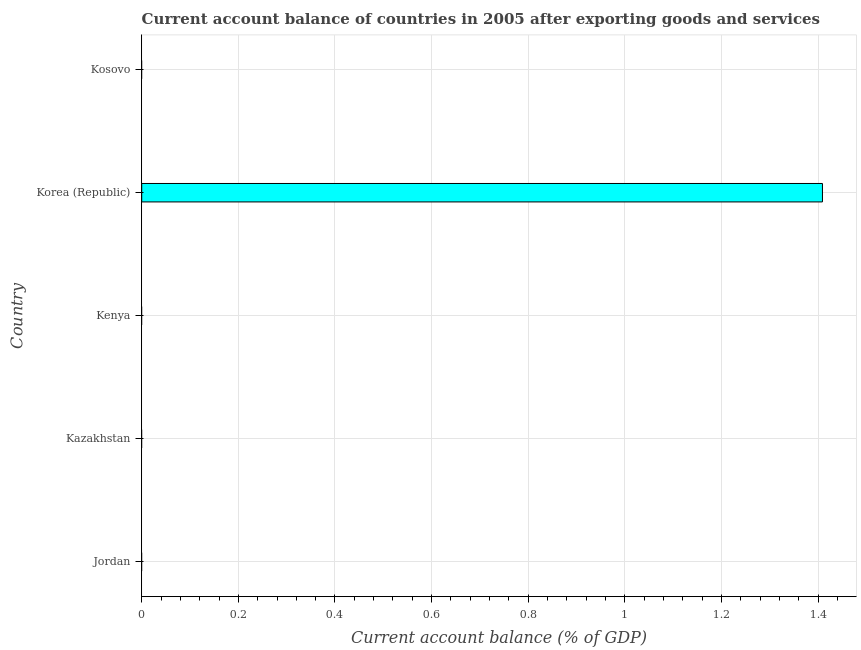Does the graph contain any zero values?
Make the answer very short. Yes. What is the title of the graph?
Provide a succinct answer. Current account balance of countries in 2005 after exporting goods and services. What is the label or title of the X-axis?
Provide a short and direct response. Current account balance (% of GDP). What is the current account balance in Kosovo?
Your answer should be very brief. 0. Across all countries, what is the maximum current account balance?
Offer a terse response. 1.41. In which country was the current account balance maximum?
Offer a terse response. Korea (Republic). What is the sum of the current account balance?
Provide a short and direct response. 1.41. What is the average current account balance per country?
Make the answer very short. 0.28. What is the median current account balance?
Offer a terse response. 0. In how many countries, is the current account balance greater than 0.56 %?
Offer a terse response. 1. What is the difference between the highest and the lowest current account balance?
Ensure brevity in your answer.  1.41. In how many countries, is the current account balance greater than the average current account balance taken over all countries?
Offer a terse response. 1. Are all the bars in the graph horizontal?
Your answer should be very brief. Yes. How many countries are there in the graph?
Give a very brief answer. 5. Are the values on the major ticks of X-axis written in scientific E-notation?
Make the answer very short. No. What is the Current account balance (% of GDP) of Jordan?
Your answer should be very brief. 0. What is the Current account balance (% of GDP) of Kazakhstan?
Ensure brevity in your answer.  0. What is the Current account balance (% of GDP) of Kenya?
Keep it short and to the point. 0. What is the Current account balance (% of GDP) in Korea (Republic)?
Keep it short and to the point. 1.41. 